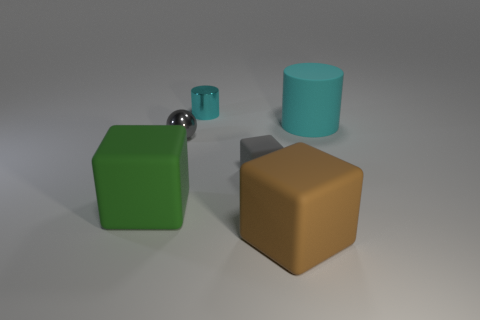Subtract all tiny gray cubes. How many cubes are left? 2 Add 3 gray metallic objects. How many objects exist? 9 Subtract all cyan cubes. Subtract all yellow cylinders. How many cubes are left? 3 Subtract all cylinders. How many objects are left? 4 Add 2 tiny gray metal things. How many tiny gray metal things exist? 3 Subtract 0 cyan balls. How many objects are left? 6 Subtract all big green cubes. Subtract all big green matte objects. How many objects are left? 4 Add 5 tiny cyan things. How many tiny cyan things are left? 6 